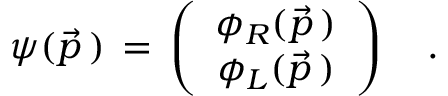Convert formula to latex. <formula><loc_0><loc_0><loc_500><loc_500>\psi ( \vec { p } \, ) \, = \, \left ( \begin{array} { c c } { { \phi _ { R } ( \vec { p } \, ) } } \\ { { \phi _ { L } ( \vec { p } \, ) } } \end{array} \right ) \quad .</formula> 